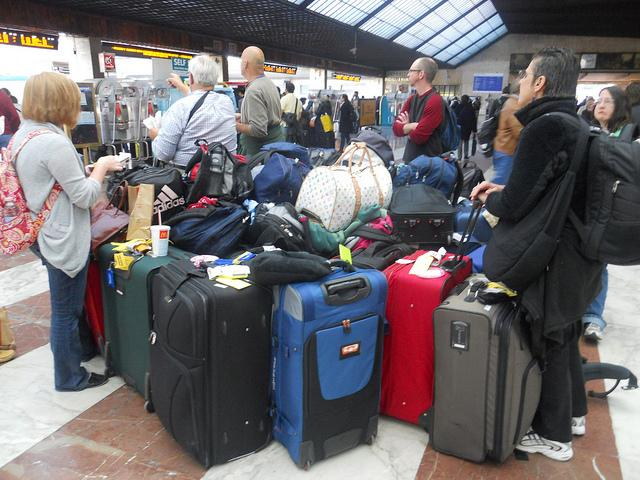What activity are these people engaged in? Please explain your reasoning. travel. The people have their suitcases with them. 